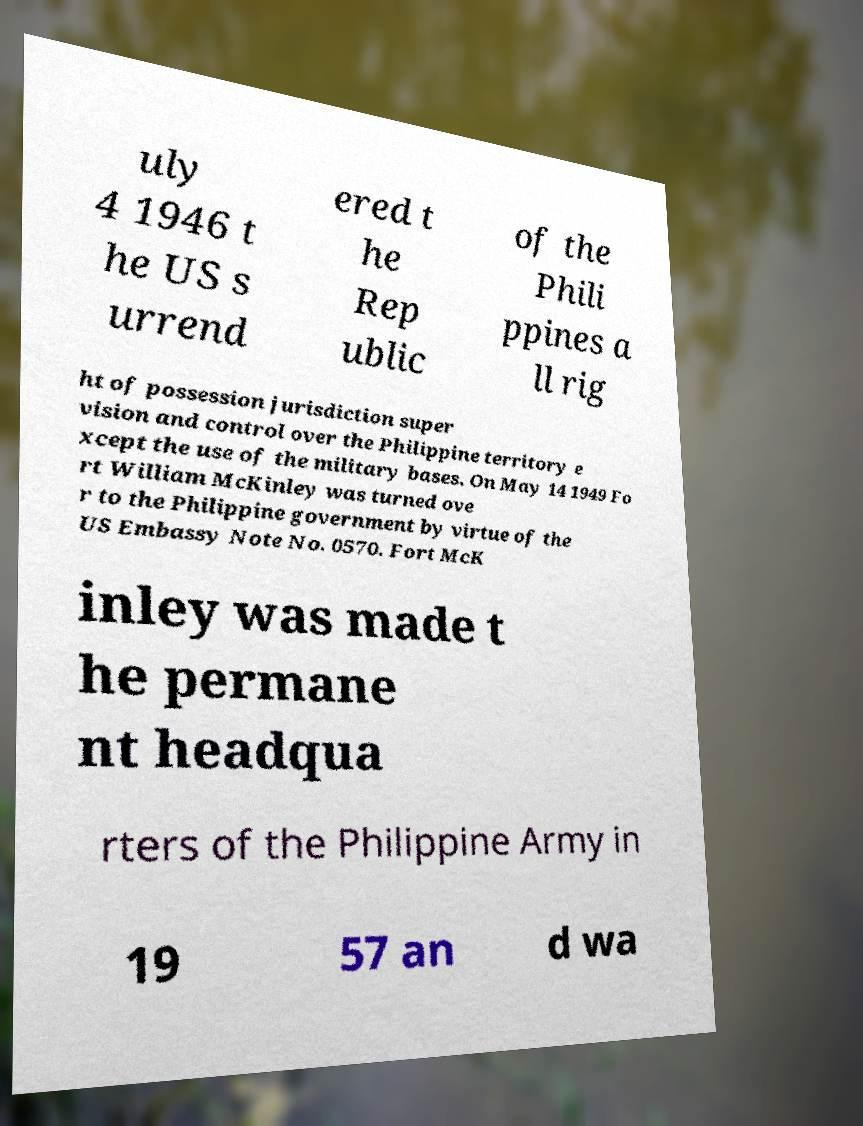There's text embedded in this image that I need extracted. Can you transcribe it verbatim? uly 4 1946 t he US s urrend ered t he Rep ublic of the Phili ppines a ll rig ht of possession jurisdiction super vision and control over the Philippine territory e xcept the use of the military bases. On May 14 1949 Fo rt William McKinley was turned ove r to the Philippine government by virtue of the US Embassy Note No. 0570. Fort McK inley was made t he permane nt headqua rters of the Philippine Army in 19 57 an d wa 